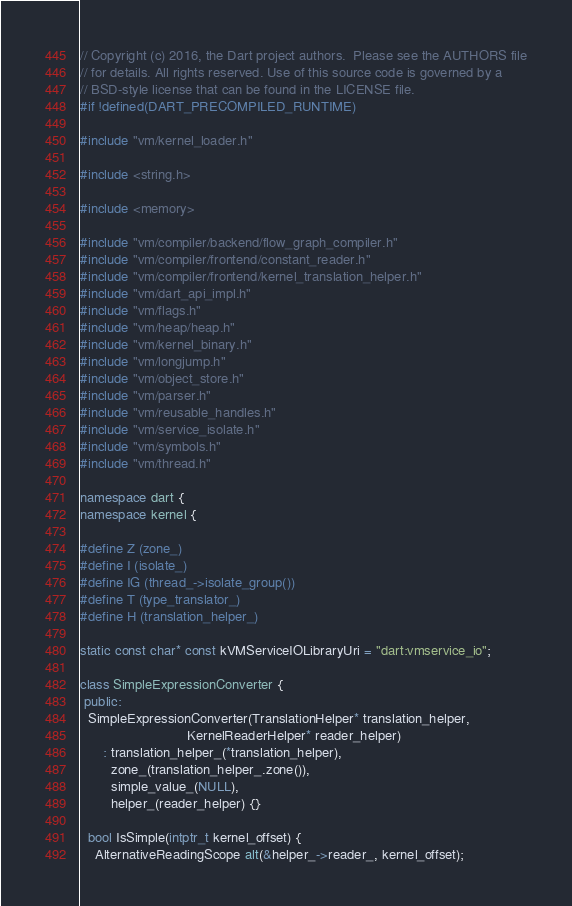Convert code to text. <code><loc_0><loc_0><loc_500><loc_500><_C++_>// Copyright (c) 2016, the Dart project authors.  Please see the AUTHORS file
// for details. All rights reserved. Use of this source code is governed by a
// BSD-style license that can be found in the LICENSE file.
#if !defined(DART_PRECOMPILED_RUNTIME)

#include "vm/kernel_loader.h"

#include <string.h>

#include <memory>

#include "vm/compiler/backend/flow_graph_compiler.h"
#include "vm/compiler/frontend/constant_reader.h"
#include "vm/compiler/frontend/kernel_translation_helper.h"
#include "vm/dart_api_impl.h"
#include "vm/flags.h"
#include "vm/heap/heap.h"
#include "vm/kernel_binary.h"
#include "vm/longjump.h"
#include "vm/object_store.h"
#include "vm/parser.h"
#include "vm/reusable_handles.h"
#include "vm/service_isolate.h"
#include "vm/symbols.h"
#include "vm/thread.h"

namespace dart {
namespace kernel {

#define Z (zone_)
#define I (isolate_)
#define IG (thread_->isolate_group())
#define T (type_translator_)
#define H (translation_helper_)

static const char* const kVMServiceIOLibraryUri = "dart:vmservice_io";

class SimpleExpressionConverter {
 public:
  SimpleExpressionConverter(TranslationHelper* translation_helper,
                            KernelReaderHelper* reader_helper)
      : translation_helper_(*translation_helper),
        zone_(translation_helper_.zone()),
        simple_value_(NULL),
        helper_(reader_helper) {}

  bool IsSimple(intptr_t kernel_offset) {
    AlternativeReadingScope alt(&helper_->reader_, kernel_offset);</code> 